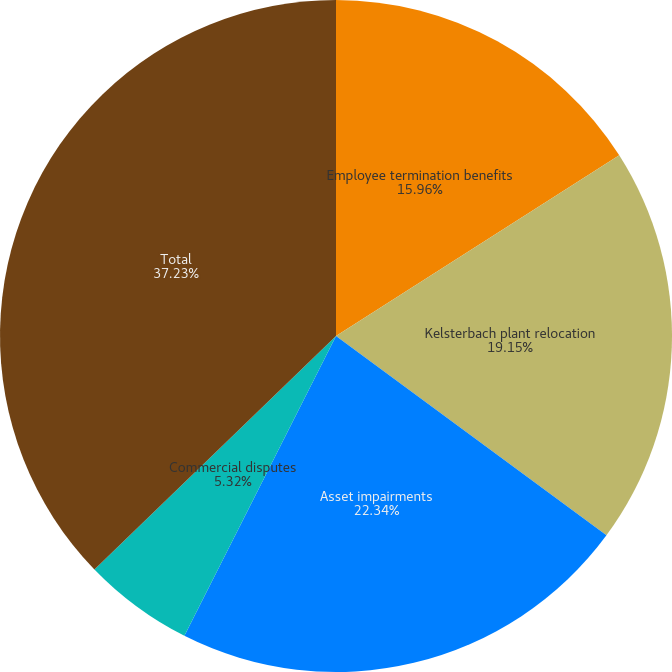Convert chart. <chart><loc_0><loc_0><loc_500><loc_500><pie_chart><fcel>Employee termination benefits<fcel>Kelsterbach plant relocation<fcel>Asset impairments<fcel>Commercial disputes<fcel>Total<nl><fcel>15.96%<fcel>19.15%<fcel>22.34%<fcel>5.32%<fcel>37.23%<nl></chart> 